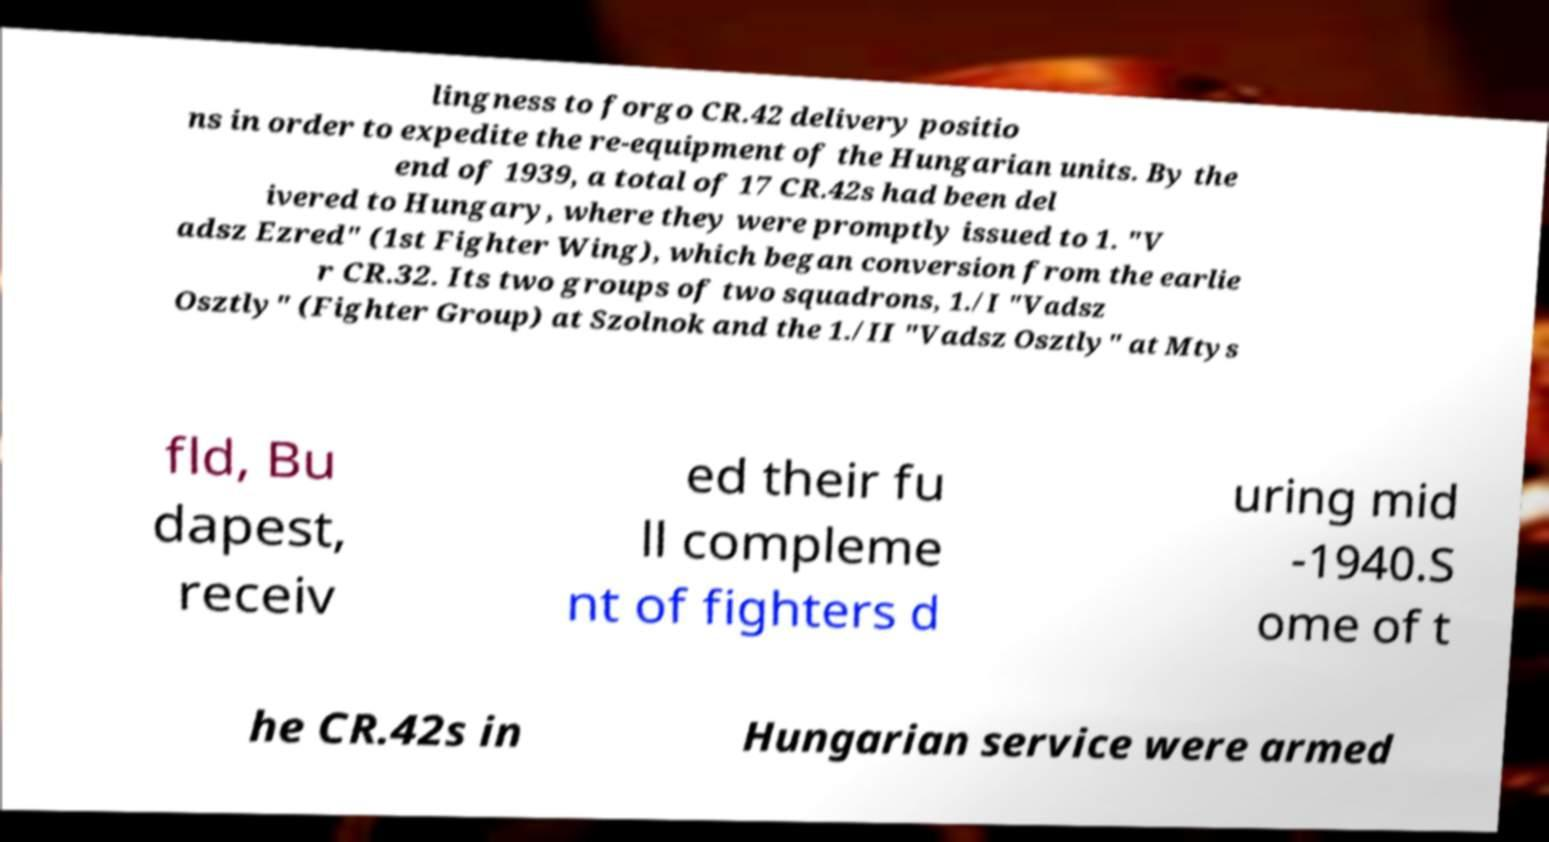Can you accurately transcribe the text from the provided image for me? lingness to forgo CR.42 delivery positio ns in order to expedite the re-equipment of the Hungarian units. By the end of 1939, a total of 17 CR.42s had been del ivered to Hungary, where they were promptly issued to 1. "V adsz Ezred" (1st Fighter Wing), which began conversion from the earlie r CR.32. Its two groups of two squadrons, 1./I "Vadsz Osztly" (Fighter Group) at Szolnok and the 1./II "Vadsz Osztly" at Mtys fld, Bu dapest, receiv ed their fu ll compleme nt of fighters d uring mid -1940.S ome of t he CR.42s in Hungarian service were armed 